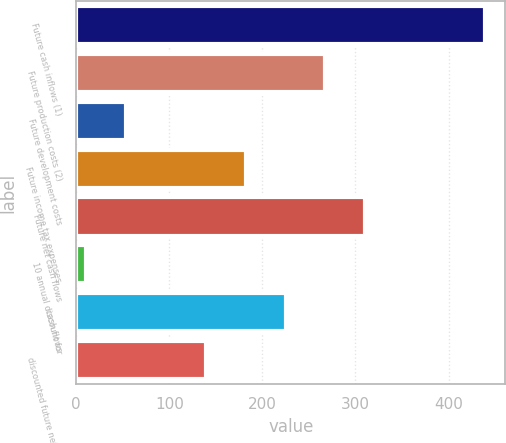Convert chart. <chart><loc_0><loc_0><loc_500><loc_500><bar_chart><fcel>Future cash inflows (1)<fcel>Future production costs (2)<fcel>Future development costs<fcel>Future income tax expenses<fcel>Future net cash flows<fcel>10 annual discount for<fcel>cash flows<fcel>discounted future net cash<nl><fcel>439<fcel>267.8<fcel>53.8<fcel>182.2<fcel>310.6<fcel>11<fcel>225<fcel>139.4<nl></chart> 